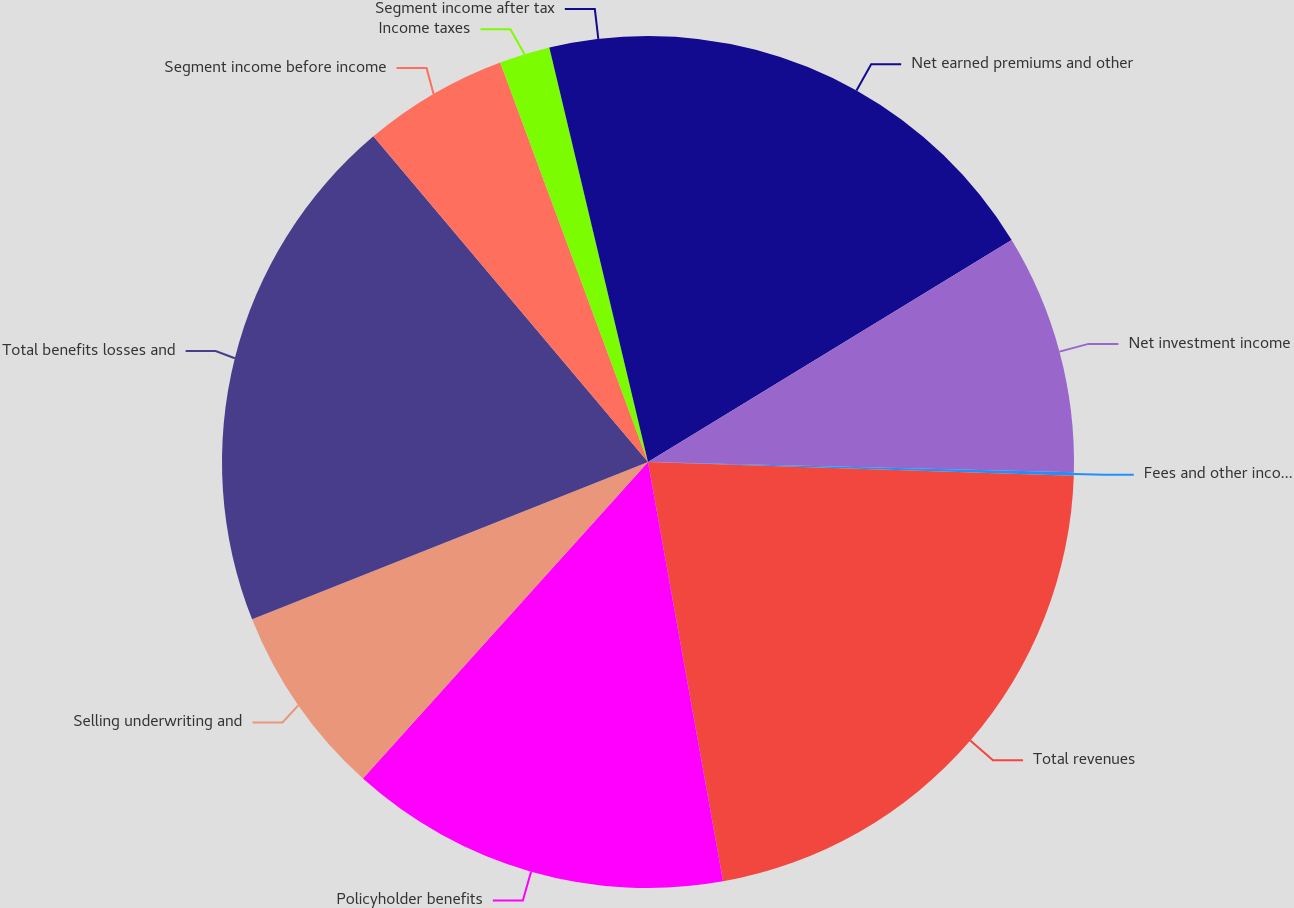Convert chart. <chart><loc_0><loc_0><loc_500><loc_500><pie_chart><fcel>Net earned premiums and other<fcel>Net investment income<fcel>Fees and other income<fcel>Total revenues<fcel>Policyholder benefits<fcel>Selling underwriting and<fcel>Total benefits losses and<fcel>Segment income before income<fcel>Income taxes<fcel>Segment income after tax<nl><fcel>16.28%<fcel>9.1%<fcel>0.13%<fcel>21.67%<fcel>14.49%<fcel>7.31%<fcel>19.87%<fcel>5.51%<fcel>1.92%<fcel>3.72%<nl></chart> 